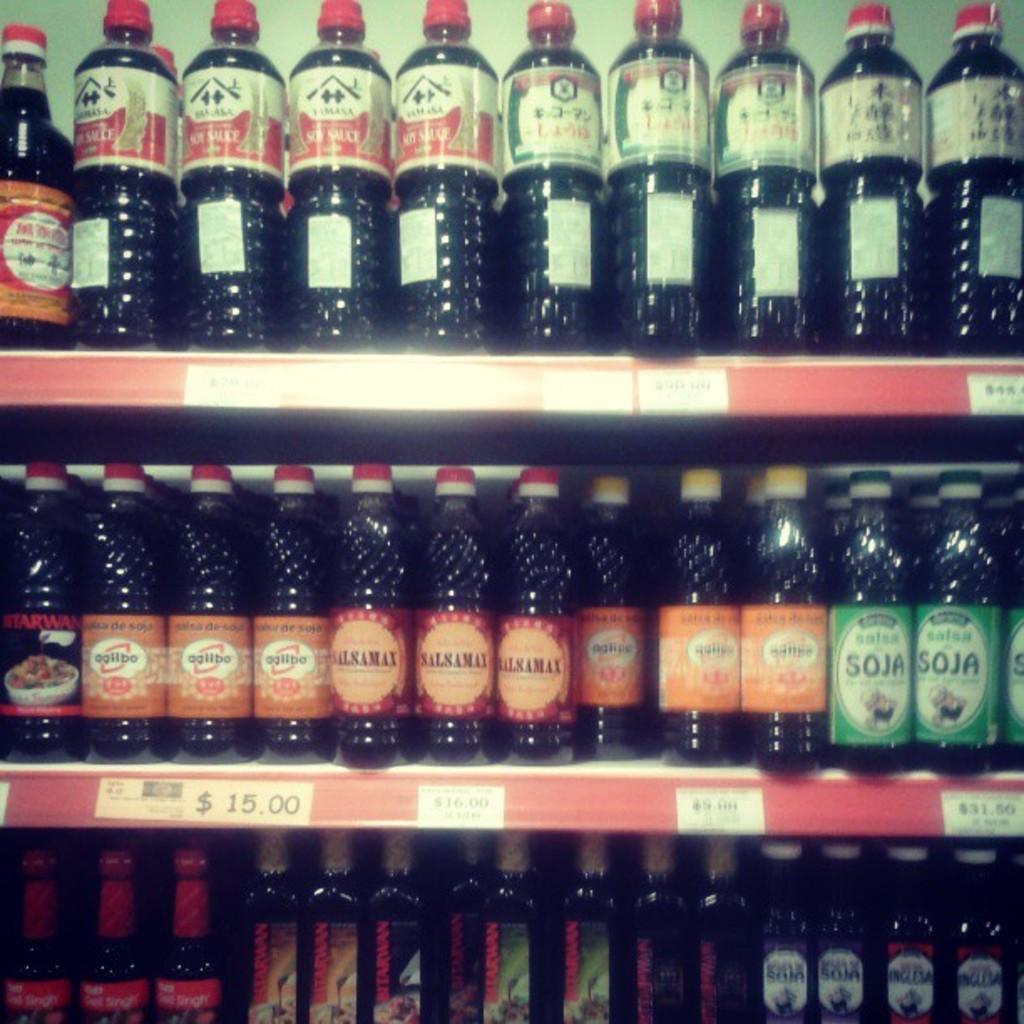Describe this image in one or two sentences. In this picture there were group of bottles in the shelves. Each bottle is labelled with different color and different text. The liquid present in the bottles is dark in color. 